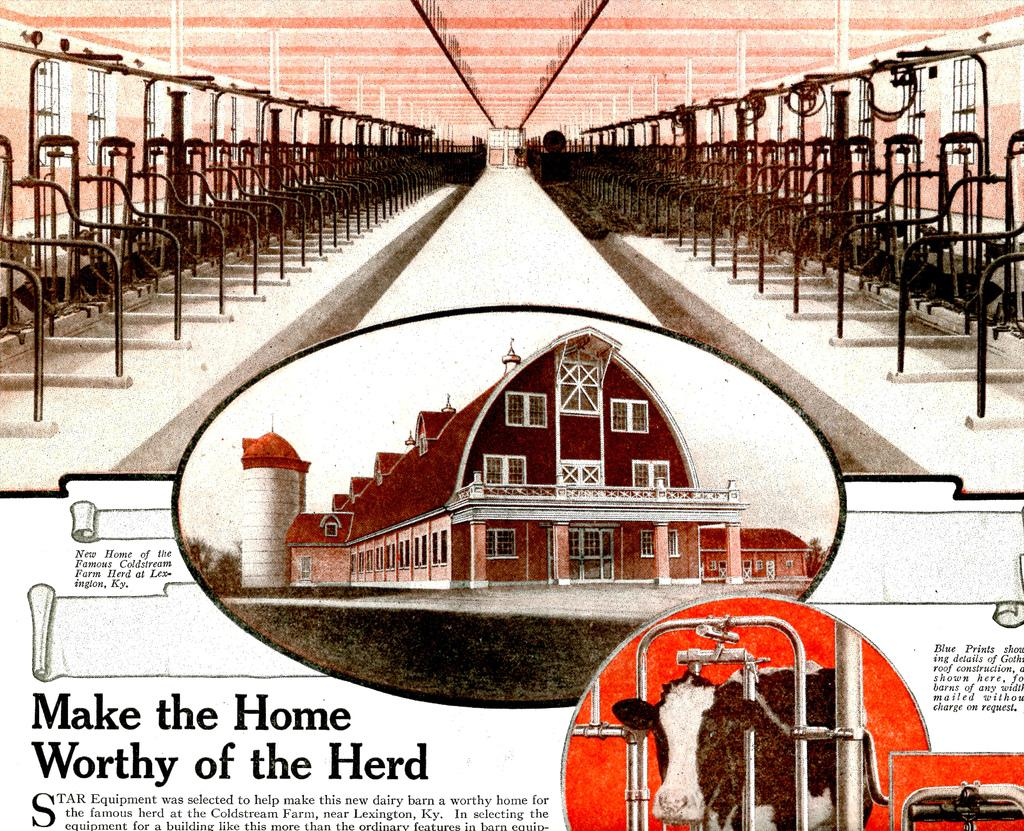<image>
Write a terse but informative summary of the picture. The milking building for cows is showing with the caption Make the Home Worthy of the Herd. 